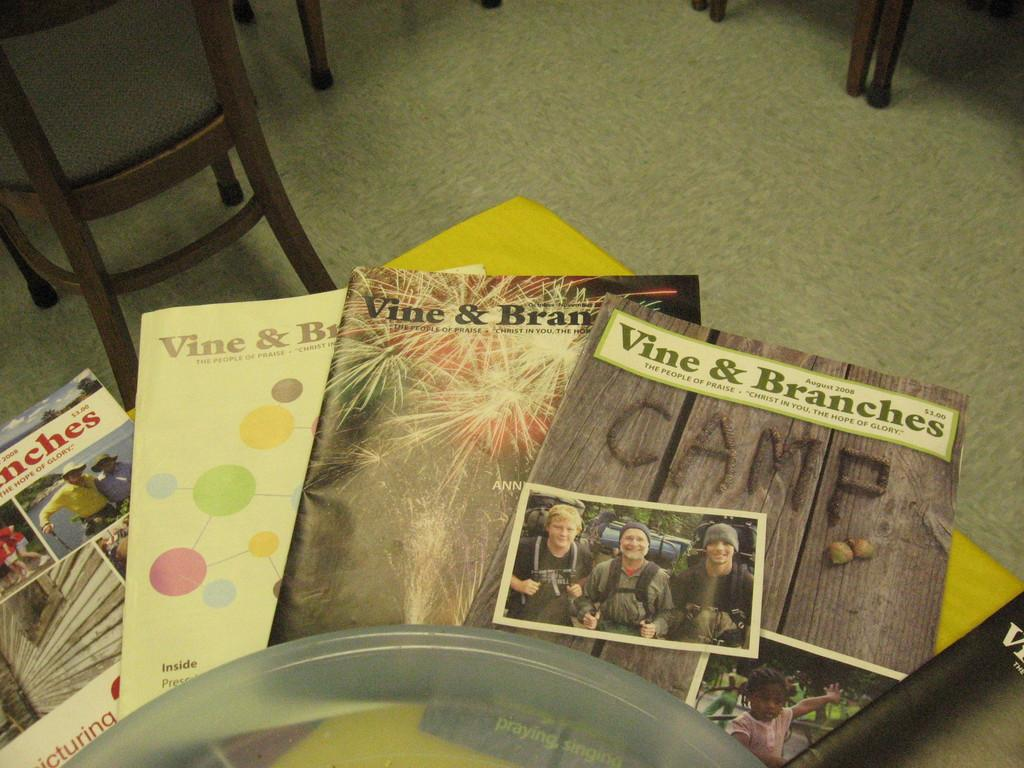Provide a one-sentence caption for the provided image. A group of magazines from Vine & branches. 